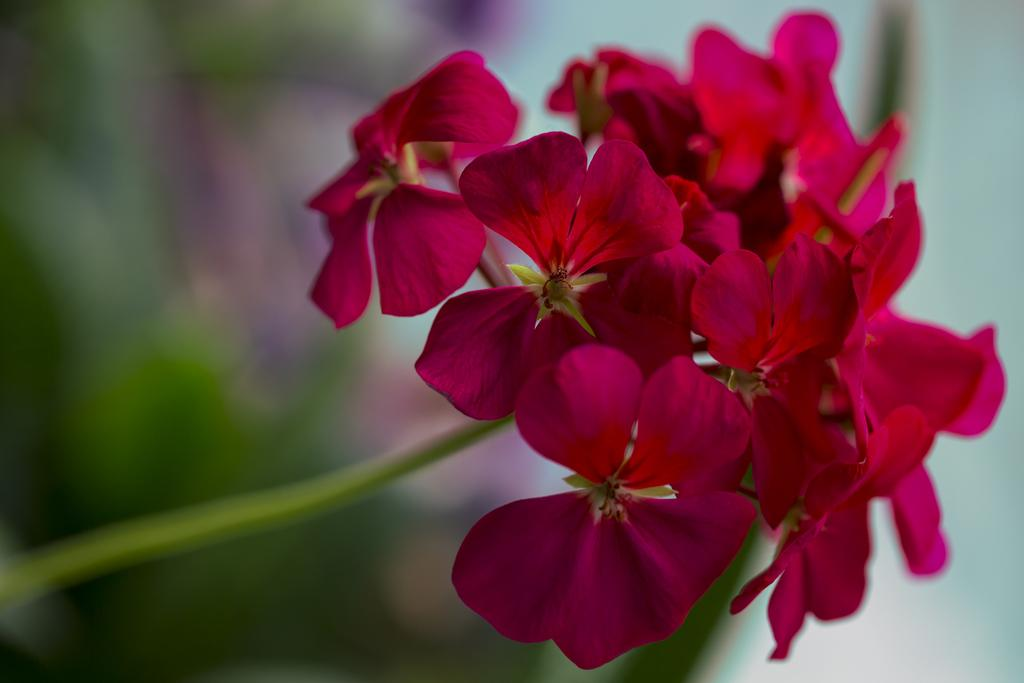What type of plants are present in the image? There are flowers in the image. Where are the flowers located in relation to the image? The flowers are in the front of the image. What part of the flowers can be seen in the image? The petals of the flowers are visible. How would you describe the background of the image? The background of the image is blurry. How does the person in the image get a nail out of the wall? There is no person or nail present in the image; it features flowers in the front with a blurry background. 